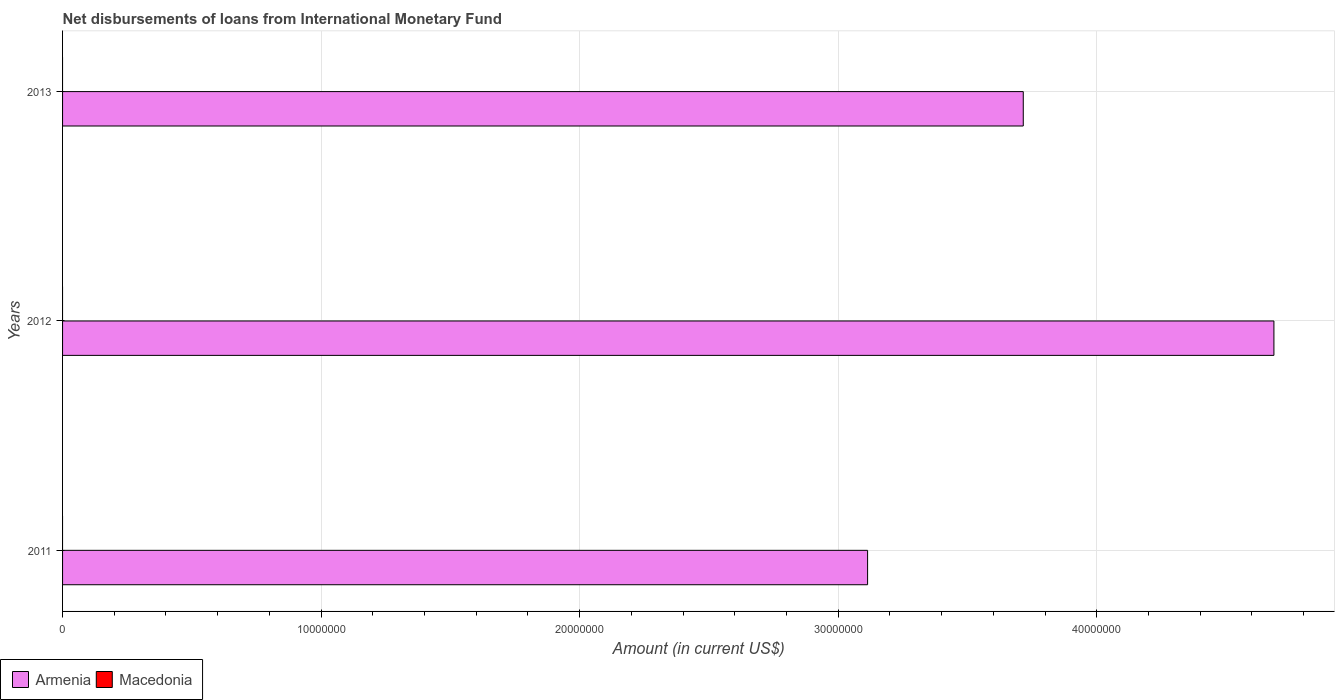How many bars are there on the 1st tick from the bottom?
Your answer should be compact. 1. What is the label of the 1st group of bars from the top?
Offer a very short reply. 2013. What is the amount of loans disbursed in Macedonia in 2013?
Your answer should be very brief. 0. Across all years, what is the maximum amount of loans disbursed in Armenia?
Your response must be concise. 4.69e+07. Across all years, what is the minimum amount of loans disbursed in Armenia?
Offer a terse response. 3.11e+07. In which year was the amount of loans disbursed in Armenia maximum?
Your response must be concise. 2012. What is the total amount of loans disbursed in Macedonia in the graph?
Your response must be concise. 0. What is the difference between the amount of loans disbursed in Armenia in 2012 and that in 2013?
Provide a short and direct response. 9.70e+06. What is the difference between the amount of loans disbursed in Armenia in 2013 and the amount of loans disbursed in Macedonia in 2012?
Offer a very short reply. 3.72e+07. What is the average amount of loans disbursed in Armenia per year?
Provide a succinct answer. 3.84e+07. In how many years, is the amount of loans disbursed in Armenia greater than 16000000 US$?
Give a very brief answer. 3. What is the ratio of the amount of loans disbursed in Armenia in 2012 to that in 2013?
Your answer should be very brief. 1.26. Is the amount of loans disbursed in Armenia in 2012 less than that in 2013?
Keep it short and to the point. No. What is the difference between the highest and the second highest amount of loans disbursed in Armenia?
Make the answer very short. 9.70e+06. What is the difference between the highest and the lowest amount of loans disbursed in Armenia?
Ensure brevity in your answer.  1.57e+07. Are the values on the major ticks of X-axis written in scientific E-notation?
Ensure brevity in your answer.  No. Does the graph contain grids?
Make the answer very short. Yes. What is the title of the graph?
Provide a succinct answer. Net disbursements of loans from International Monetary Fund. Does "Poland" appear as one of the legend labels in the graph?
Provide a succinct answer. No. What is the Amount (in current US$) in Armenia in 2011?
Make the answer very short. 3.11e+07. What is the Amount (in current US$) of Armenia in 2012?
Offer a terse response. 4.69e+07. What is the Amount (in current US$) of Macedonia in 2012?
Your answer should be compact. 0. What is the Amount (in current US$) in Armenia in 2013?
Your answer should be compact. 3.72e+07. What is the Amount (in current US$) in Macedonia in 2013?
Give a very brief answer. 0. Across all years, what is the maximum Amount (in current US$) of Armenia?
Offer a terse response. 4.69e+07. Across all years, what is the minimum Amount (in current US$) of Armenia?
Give a very brief answer. 3.11e+07. What is the total Amount (in current US$) of Armenia in the graph?
Offer a terse response. 1.15e+08. What is the total Amount (in current US$) of Macedonia in the graph?
Your response must be concise. 0. What is the difference between the Amount (in current US$) in Armenia in 2011 and that in 2012?
Your answer should be very brief. -1.57e+07. What is the difference between the Amount (in current US$) of Armenia in 2011 and that in 2013?
Keep it short and to the point. -6.02e+06. What is the difference between the Amount (in current US$) in Armenia in 2012 and that in 2013?
Ensure brevity in your answer.  9.70e+06. What is the average Amount (in current US$) of Armenia per year?
Ensure brevity in your answer.  3.84e+07. What is the ratio of the Amount (in current US$) in Armenia in 2011 to that in 2012?
Offer a very short reply. 0.66. What is the ratio of the Amount (in current US$) in Armenia in 2011 to that in 2013?
Your answer should be compact. 0.84. What is the ratio of the Amount (in current US$) in Armenia in 2012 to that in 2013?
Your answer should be compact. 1.26. What is the difference between the highest and the second highest Amount (in current US$) of Armenia?
Offer a terse response. 9.70e+06. What is the difference between the highest and the lowest Amount (in current US$) of Armenia?
Provide a succinct answer. 1.57e+07. 